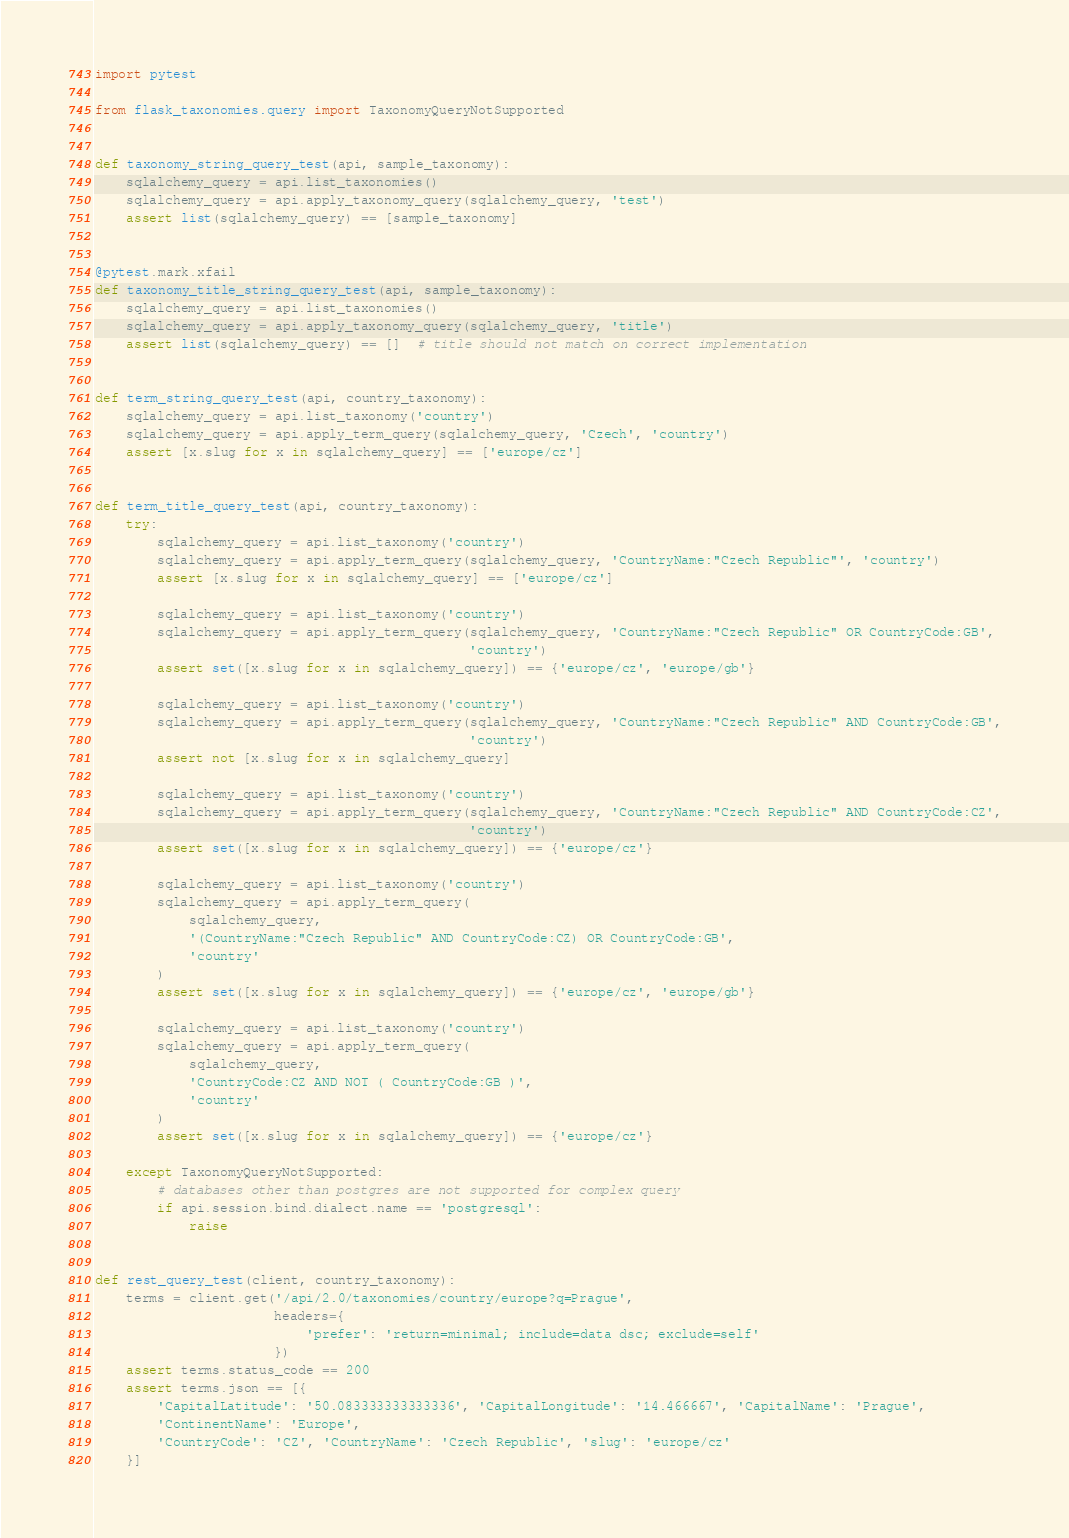Convert code to text. <code><loc_0><loc_0><loc_500><loc_500><_Python_>import pytest

from flask_taxonomies.query import TaxonomyQueryNotSupported


def taxonomy_string_query_test(api, sample_taxonomy):
    sqlalchemy_query = api.list_taxonomies()
    sqlalchemy_query = api.apply_taxonomy_query(sqlalchemy_query, 'test')
    assert list(sqlalchemy_query) == [sample_taxonomy]


@pytest.mark.xfail
def taxonomy_title_string_query_test(api, sample_taxonomy):
    sqlalchemy_query = api.list_taxonomies()
    sqlalchemy_query = api.apply_taxonomy_query(sqlalchemy_query, 'title')
    assert list(sqlalchemy_query) == []  # title should not match on correct implementation


def term_string_query_test(api, country_taxonomy):
    sqlalchemy_query = api.list_taxonomy('country')
    sqlalchemy_query = api.apply_term_query(sqlalchemy_query, 'Czech', 'country')
    assert [x.slug for x in sqlalchemy_query] == ['europe/cz']


def term_title_query_test(api, country_taxonomy):
    try:
        sqlalchemy_query = api.list_taxonomy('country')
        sqlalchemy_query = api.apply_term_query(sqlalchemy_query, 'CountryName:"Czech Republic"', 'country')
        assert [x.slug for x in sqlalchemy_query] == ['europe/cz']

        sqlalchemy_query = api.list_taxonomy('country')
        sqlalchemy_query = api.apply_term_query(sqlalchemy_query, 'CountryName:"Czech Republic" OR CountryCode:GB',
                                                'country')
        assert set([x.slug for x in sqlalchemy_query]) == {'europe/cz', 'europe/gb'}

        sqlalchemy_query = api.list_taxonomy('country')
        sqlalchemy_query = api.apply_term_query(sqlalchemy_query, 'CountryName:"Czech Republic" AND CountryCode:GB',
                                                'country')
        assert not [x.slug for x in sqlalchemy_query]

        sqlalchemy_query = api.list_taxonomy('country')
        sqlalchemy_query = api.apply_term_query(sqlalchemy_query, 'CountryName:"Czech Republic" AND CountryCode:CZ',
                                                'country')
        assert set([x.slug for x in sqlalchemy_query]) == {'europe/cz'}

        sqlalchemy_query = api.list_taxonomy('country')
        sqlalchemy_query = api.apply_term_query(
            sqlalchemy_query,
            '(CountryName:"Czech Republic" AND CountryCode:CZ) OR CountryCode:GB',
            'country'
        )
        assert set([x.slug for x in sqlalchemy_query]) == {'europe/cz', 'europe/gb'}

        sqlalchemy_query = api.list_taxonomy('country')
        sqlalchemy_query = api.apply_term_query(
            sqlalchemy_query,
            'CountryCode:CZ AND NOT ( CountryCode:GB )',
            'country'
        )
        assert set([x.slug for x in sqlalchemy_query]) == {'europe/cz'}

    except TaxonomyQueryNotSupported:
        # databases other than postgres are not supported for complex query
        if api.session.bind.dialect.name == 'postgresql':
            raise


def rest_query_test(client, country_taxonomy):
    terms = client.get('/api/2.0/taxonomies/country/europe?q=Prague',
                       headers={
                           'prefer': 'return=minimal; include=data dsc; exclude=self'
                       })
    assert terms.status_code == 200
    assert terms.json == [{
        'CapitalLatitude': '50.083333333333336', 'CapitalLongitude': '14.466667', 'CapitalName': 'Prague',
        'ContinentName': 'Europe',
        'CountryCode': 'CZ', 'CountryName': 'Czech Republic', 'slug': 'europe/cz'
    }]
</code> 